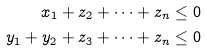<formula> <loc_0><loc_0><loc_500><loc_500>x _ { 1 } + z _ { 2 } + \dots + z _ { n } \leq 0 \\ y _ { 1 } + y _ { 2 } + z _ { 3 } + \dots + z _ { n } \leq 0</formula> 